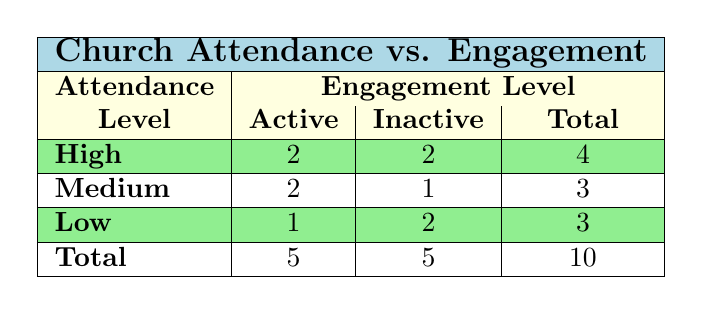What is the total number of churches with high attendance? From the table, we can find that under the "High" attendance level, there are a total of 4 churches listed.
Answer: 4 How many churches have active engagement with medium attendance? Looking at the medium attendance row, we see that there are 2 churches that have an active engagement level.
Answer: 2 What is the difference between the number of churches with active engagement and those with inactive engagement? The total number of churches with active engagement is 5, and the total with inactive engagement is also 5. The difference is 5 - 5 = 0.
Answer: 0 Do any churches with low attendance have active engagement? Yes, there is 1 church listed with low attendance that has active engagement (Zion Lutheran Church).
Answer: Yes What is the total number of churches with inactive engagement? Summing the churches with inactive engagement from each attendance level gives us 2 (High) + 1 (Medium) + 2 (Low) = 5.
Answer: 5 How does the number of churches with high attendance compare to those with low attendance in terms of engagement? For high attendance, there are 2 active and 2 inactive churches, summing to 4. For low attendance, there is 1 active and 2 inactive, summing to 3. High attendance has 1 more church engaged (active + inactive) compared to low attendance.
Answer: High attendance has more What is the percentage of inactive churches among those with medium attendance? There is 1 inactive church in the medium attendance level out of a total of 3 churches (2 active + 1 inactive). The percentage is calculated as (1 inactive / 3 total) * 100, which is approximately 33.33%.
Answer: 33.33% How many churches are there in total that have both high attendance and active engagement? There are 2 churches listed under the "High" attendance level with "Active" engagement.
Answer: 2 Which attendance level has the highest total number of churches? The attendance level with the highest total churches is High, with a total of 4 (2 active + 2 inactive).
Answer: High How many more churches have active engagement compared to low attendance? There are 5 churches with active engagement and 3 with low attendance; therefore the difference is 5 - 3 = 2.
Answer: 2 